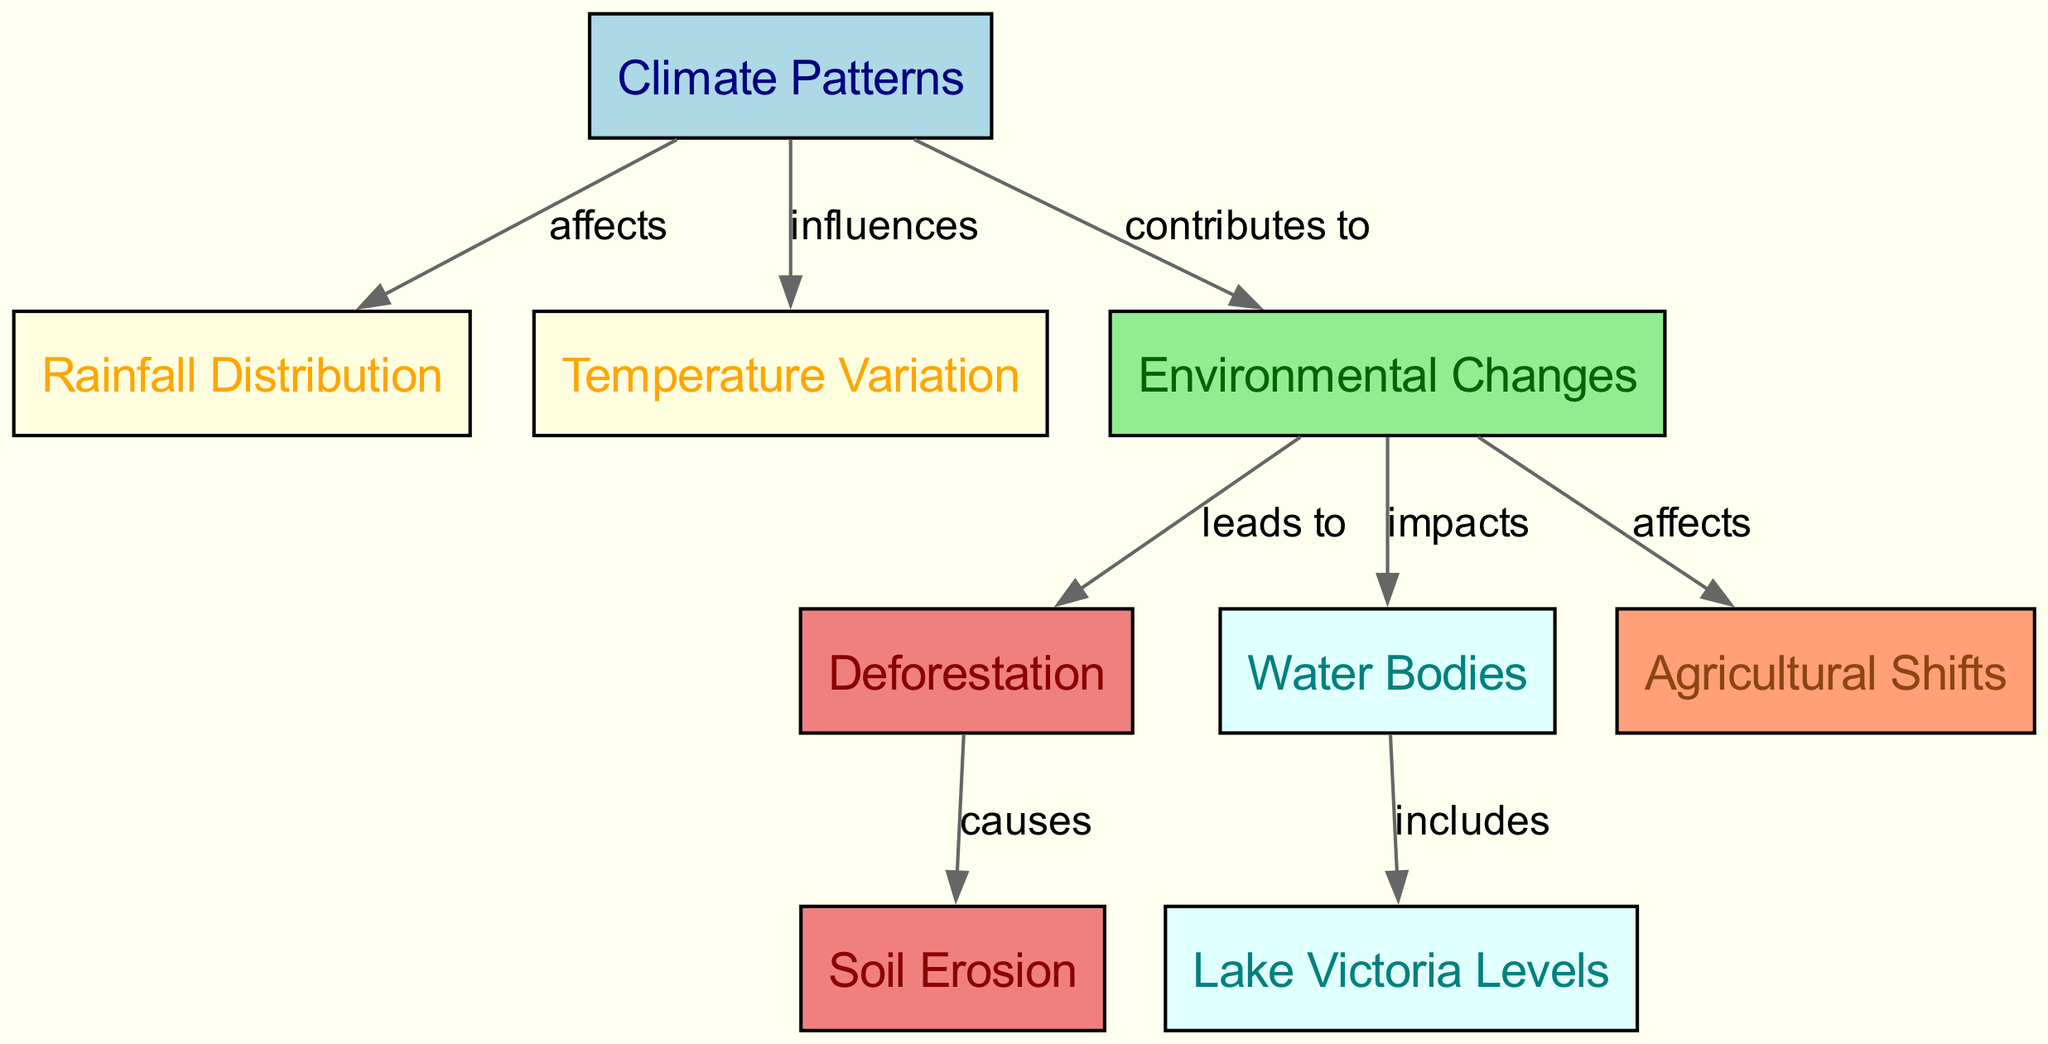What are the two primary climate factors displayed in the diagram? The diagram has two nodes connected to the "Climate Patterns" node: "Rainfall Distribution" and "Temperature Variation". Therefore, the primary climate factors are rainfall and temperature.
Answer: Rainfall Distribution and Temperature Variation How many nodes are represented in the diagram? The diagram contains a total of 8 nodes: "Climate Patterns," "Rainfall Distribution," "Temperature Variation," "Environmental Changes," "Deforestation," "Soil Erosion," "Water Bodies," and "Lake Victoria Levels." Therefore, the total count is eight.
Answer: 8 What consequence does environmental change lead to, as highlighted in the diagram? The "Environmental Changes" node points to "Deforestation," indicating that environmental changes lead to deforestation.
Answer: Deforestation Which node is specifically influenced by climate patterns as shown in the diagram? The "Temperature Variation" and "Rainfall Distribution" nodes are influenced by the "Climate Patterns" node, indicating both are impacted by climate variations.
Answer: Temperature Variation What does deforestation cause in the context of the diagram? According to the diagram, "Deforestation" leads to "Soil Erosion." This indicates that one result of deforestation is increased soil erosion.
Answer: Soil Erosion How does environmental change affect agriculture according to the diagram? The diagram shows an edge indicating that "Environmental Changes" affects "Agricultural Shifts." Thus, environmental changes have an impact on agriculture.
Answer: Agricultural Shifts What are the water bodies included in environmental changes? Within the diagram, "Water Bodies" connects to "Lake Victoria Levels," meaning Lake Victoria is a specific part of the water bodies affected by environmental changes.
Answer: Lake Victoria Levels What relationship exists between climate patterns and environmental changes? The diagram explicitly states that "Climate Patterns" contributes to "Environmental Changes," indicating a supportive relationship.
Answer: Contributes to What is the color of the node representing deforestation? In the diagram, the "Deforestation" node is colored light coral, which visually represents this specific environmental issue.
Answer: Light coral 